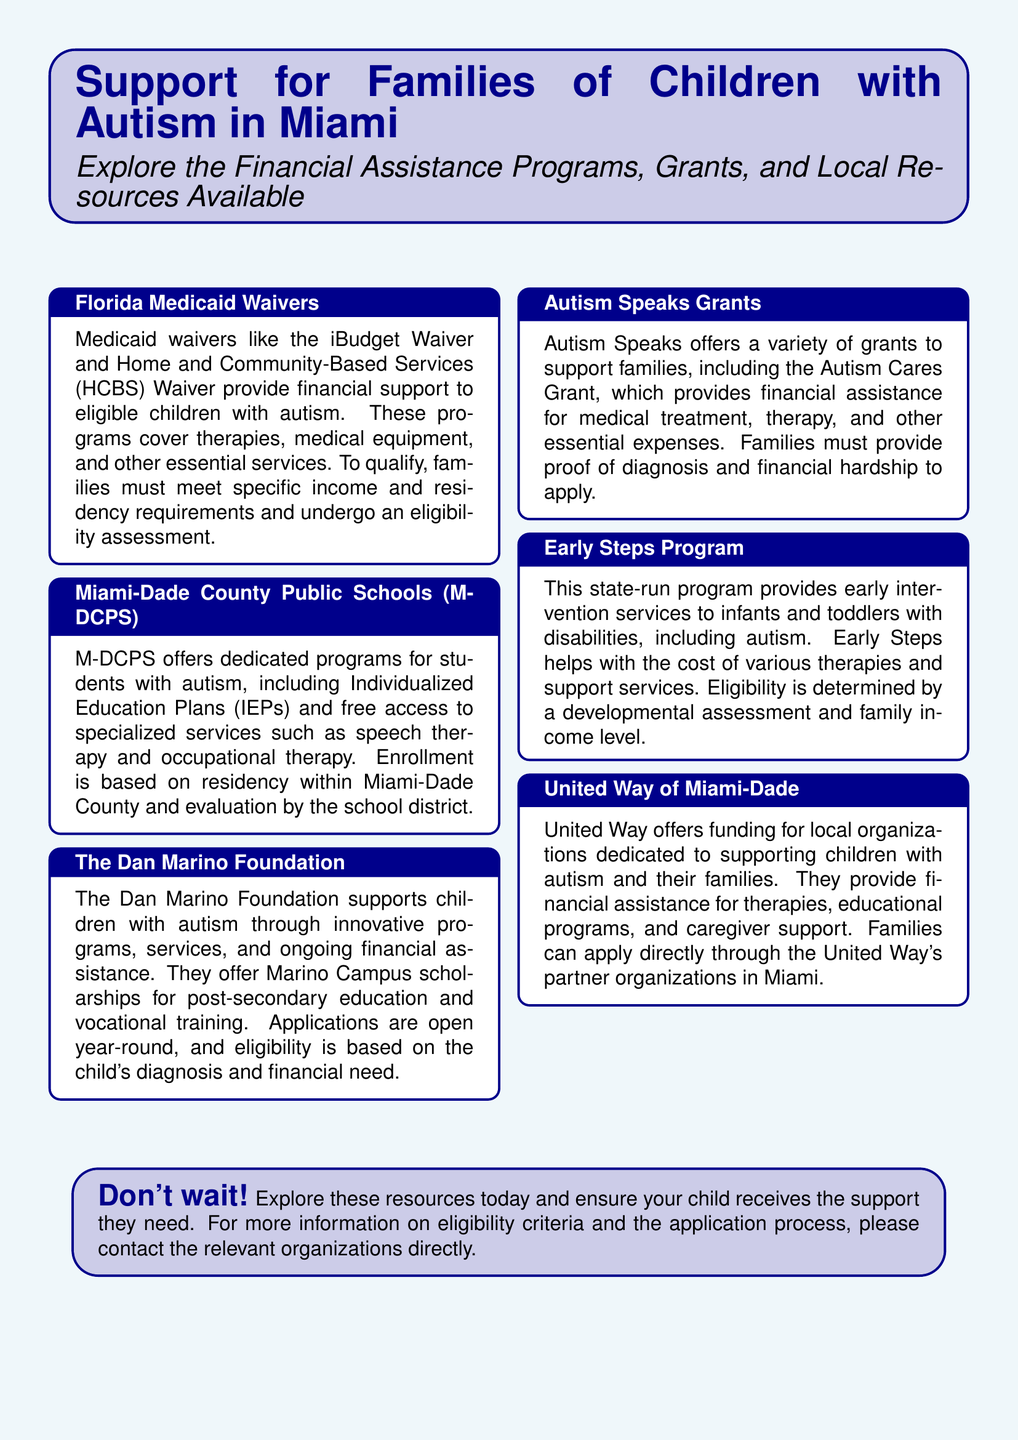What is the name of the waivers that provide financial support? The document mentions the iBudget Waiver and the Home and Community-Based Services (HCBS) Waiver as Medicaid waivers that provide financial support.
Answer: iBudget Waiver, HCBS Waiver Who offers Individualized Education Plans for students with autism? Miami-Dade County Public Schools provides dedicated programs and Individualized Education Plans for students with autism.
Answer: M-DCPS What type of grants does Autism Speaks offer? The document states that Autism Speaks offers grants like the Autism Cares Grant for medical treatment and therapy expenses.
Answer: Autism Cares Grant What organization supports children with autism through Marino Campus scholarships? The Dan Marino Foundation is mentioned as supporting children with autism through Marino Campus scholarships for post-secondary education.
Answer: The Dan Marino Foundation Which program provides early intervention services to infants and toddlers? The Early Steps Program is highlighted in the document as a state-run program for early intervention services.
Answer: Early Steps Program What is the eligibility criterion for the Autism Speaks Grants? Families must provide proof of diagnosis and financial hardship to apply for Autism Speaks Grants.
Answer: Proof of diagnosis and financial hardship Which local organization offers funding for educational programs for children with autism? United Way of Miami-Dade offers funding for local organizations dedicated to supporting children with autism and educational programs.
Answer: United Way of Miami-Dade What must families do to qualify for Florida Medicaid Waivers? Families must meet specific income and residency requirements and undergo an eligibility assessment to qualify for Florida Medicaid Waivers.
Answer: Eligibility assessment What is a benefit offered by M-DCPS for children with autism? M-DCPS offers free access to specialized services such as speech therapy and occupational therapy for children with autism.
Answer: Free access to specialized services 